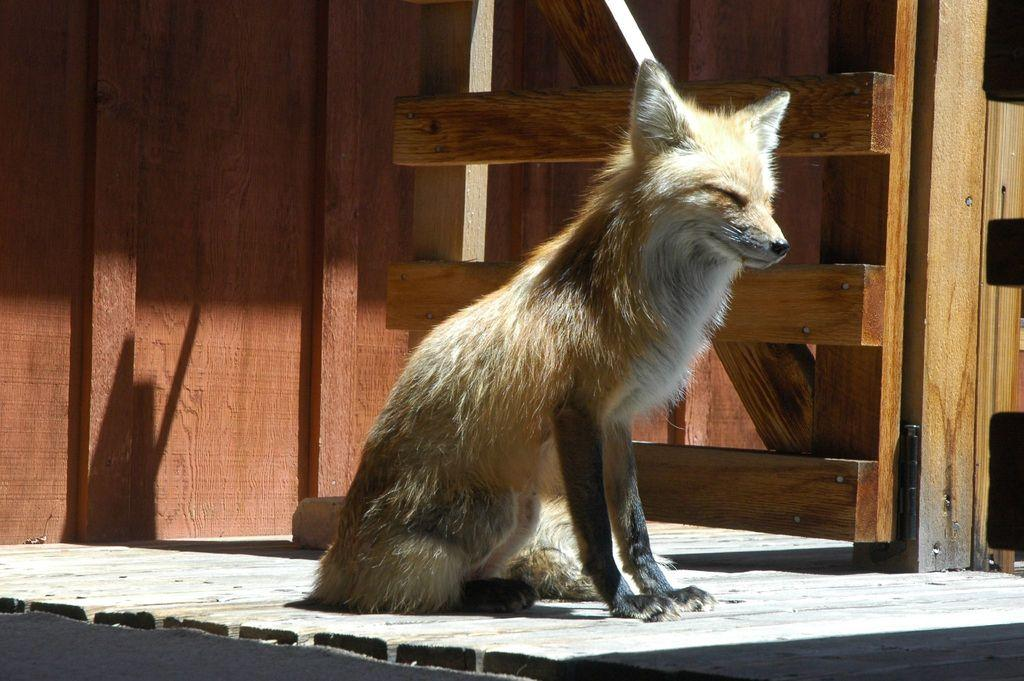What animal can be seen in the image? There is a fox in the image. What type of material is used for the railing in the image? The railing in the image is made of wood. What can be seen in the background of the image? There is a wooden wall in the background of the image. What is the color of the wooden wall? The wooden wall is brown in color. What type of flooring is visible at the bottom of the image? There is a wooden floor visible at the bottom of the image. What type of soap is used to clean the wooden floor in the image? There is no soap present in the image, and the wooden floor's cleanliness is not mentioned. 